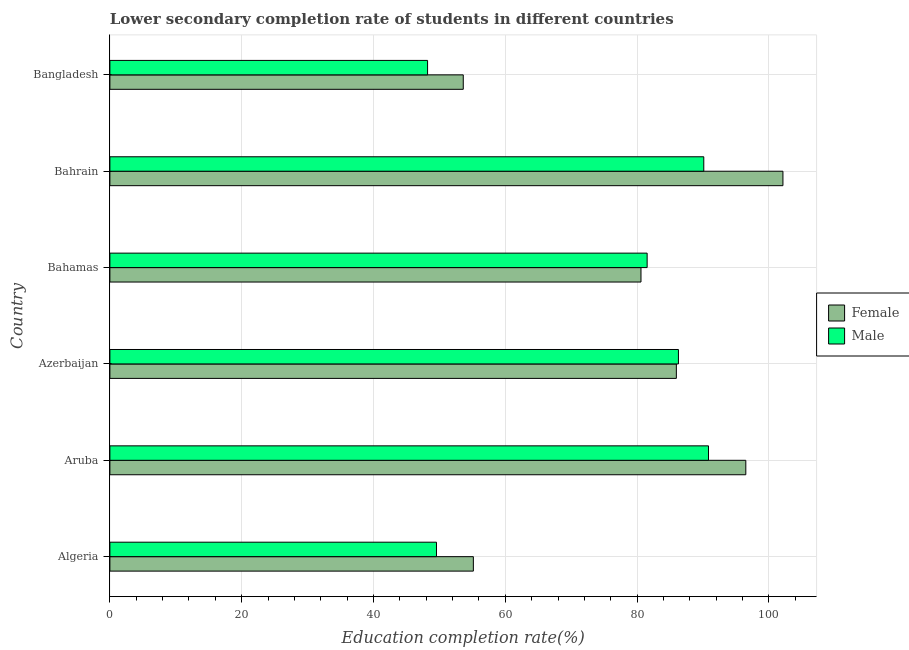How many different coloured bars are there?
Your response must be concise. 2. Are the number of bars per tick equal to the number of legend labels?
Provide a short and direct response. Yes. How many bars are there on the 3rd tick from the bottom?
Offer a terse response. 2. What is the education completion rate of male students in Aruba?
Offer a terse response. 90.82. Across all countries, what is the maximum education completion rate of male students?
Offer a terse response. 90.82. Across all countries, what is the minimum education completion rate of female students?
Give a very brief answer. 53.62. In which country was the education completion rate of female students maximum?
Offer a very short reply. Bahrain. What is the total education completion rate of female students in the graph?
Offer a very short reply. 473.9. What is the difference between the education completion rate of male students in Algeria and that in Bangladesh?
Your answer should be very brief. 1.35. What is the difference between the education completion rate of female students in Azerbaijan and the education completion rate of male students in Bahamas?
Offer a terse response. 4.43. What is the average education completion rate of female students per country?
Your answer should be compact. 78.98. What is the difference between the education completion rate of male students and education completion rate of female students in Bahrain?
Make the answer very short. -12.01. What is the ratio of the education completion rate of male students in Bahamas to that in Bangladesh?
Give a very brief answer. 1.69. What is the difference between the highest and the second highest education completion rate of male students?
Provide a short and direct response. 0.72. What is the difference between the highest and the lowest education completion rate of male students?
Your response must be concise. 42.62. What does the 2nd bar from the bottom in Azerbaijan represents?
Provide a succinct answer. Male. Are all the bars in the graph horizontal?
Your response must be concise. Yes. How many countries are there in the graph?
Provide a succinct answer. 6. What is the difference between two consecutive major ticks on the X-axis?
Provide a succinct answer. 20. Are the values on the major ticks of X-axis written in scientific E-notation?
Keep it short and to the point. No. Does the graph contain any zero values?
Give a very brief answer. No. Does the graph contain grids?
Provide a short and direct response. Yes. Where does the legend appear in the graph?
Give a very brief answer. Center right. How many legend labels are there?
Ensure brevity in your answer.  2. How are the legend labels stacked?
Give a very brief answer. Vertical. What is the title of the graph?
Give a very brief answer. Lower secondary completion rate of students in different countries. Does "Primary school" appear as one of the legend labels in the graph?
Ensure brevity in your answer.  No. What is the label or title of the X-axis?
Give a very brief answer. Education completion rate(%). What is the Education completion rate(%) in Female in Algeria?
Give a very brief answer. 55.15. What is the Education completion rate(%) of Male in Algeria?
Keep it short and to the point. 49.55. What is the Education completion rate(%) of Female in Aruba?
Your response must be concise. 96.49. What is the Education completion rate(%) of Male in Aruba?
Your answer should be compact. 90.82. What is the Education completion rate(%) in Female in Azerbaijan?
Provide a short and direct response. 85.95. What is the Education completion rate(%) in Male in Azerbaijan?
Give a very brief answer. 86.26. What is the Education completion rate(%) in Female in Bahamas?
Your response must be concise. 80.58. What is the Education completion rate(%) of Male in Bahamas?
Offer a very short reply. 81.51. What is the Education completion rate(%) in Female in Bahrain?
Provide a short and direct response. 102.12. What is the Education completion rate(%) of Male in Bahrain?
Make the answer very short. 90.11. What is the Education completion rate(%) in Female in Bangladesh?
Your answer should be very brief. 53.62. What is the Education completion rate(%) of Male in Bangladesh?
Provide a short and direct response. 48.2. Across all countries, what is the maximum Education completion rate(%) in Female?
Offer a terse response. 102.12. Across all countries, what is the maximum Education completion rate(%) of Male?
Offer a very short reply. 90.82. Across all countries, what is the minimum Education completion rate(%) in Female?
Ensure brevity in your answer.  53.62. Across all countries, what is the minimum Education completion rate(%) in Male?
Make the answer very short. 48.2. What is the total Education completion rate(%) in Female in the graph?
Offer a terse response. 473.9. What is the total Education completion rate(%) in Male in the graph?
Offer a very short reply. 446.46. What is the difference between the Education completion rate(%) in Female in Algeria and that in Aruba?
Keep it short and to the point. -41.34. What is the difference between the Education completion rate(%) of Male in Algeria and that in Aruba?
Your answer should be very brief. -41.27. What is the difference between the Education completion rate(%) in Female in Algeria and that in Azerbaijan?
Offer a terse response. -30.8. What is the difference between the Education completion rate(%) of Male in Algeria and that in Azerbaijan?
Provide a short and direct response. -36.71. What is the difference between the Education completion rate(%) of Female in Algeria and that in Bahamas?
Offer a very short reply. -25.44. What is the difference between the Education completion rate(%) of Male in Algeria and that in Bahamas?
Provide a short and direct response. -31.96. What is the difference between the Education completion rate(%) of Female in Algeria and that in Bahrain?
Your answer should be compact. -46.97. What is the difference between the Education completion rate(%) in Male in Algeria and that in Bahrain?
Give a very brief answer. -40.56. What is the difference between the Education completion rate(%) of Female in Algeria and that in Bangladesh?
Ensure brevity in your answer.  1.53. What is the difference between the Education completion rate(%) of Male in Algeria and that in Bangladesh?
Your answer should be compact. 1.35. What is the difference between the Education completion rate(%) of Female in Aruba and that in Azerbaijan?
Your answer should be very brief. 10.54. What is the difference between the Education completion rate(%) in Male in Aruba and that in Azerbaijan?
Provide a short and direct response. 4.56. What is the difference between the Education completion rate(%) in Female in Aruba and that in Bahamas?
Keep it short and to the point. 15.9. What is the difference between the Education completion rate(%) in Male in Aruba and that in Bahamas?
Provide a short and direct response. 9.31. What is the difference between the Education completion rate(%) in Female in Aruba and that in Bahrain?
Make the answer very short. -5.63. What is the difference between the Education completion rate(%) of Male in Aruba and that in Bahrain?
Offer a terse response. 0.72. What is the difference between the Education completion rate(%) in Female in Aruba and that in Bangladesh?
Your response must be concise. 42.87. What is the difference between the Education completion rate(%) in Male in Aruba and that in Bangladesh?
Offer a terse response. 42.62. What is the difference between the Education completion rate(%) of Female in Azerbaijan and that in Bahamas?
Ensure brevity in your answer.  5.37. What is the difference between the Education completion rate(%) of Male in Azerbaijan and that in Bahamas?
Provide a succinct answer. 4.75. What is the difference between the Education completion rate(%) in Female in Azerbaijan and that in Bahrain?
Provide a succinct answer. -16.17. What is the difference between the Education completion rate(%) of Male in Azerbaijan and that in Bahrain?
Offer a terse response. -3.84. What is the difference between the Education completion rate(%) of Female in Azerbaijan and that in Bangladesh?
Keep it short and to the point. 32.33. What is the difference between the Education completion rate(%) in Male in Azerbaijan and that in Bangladesh?
Make the answer very short. 38.06. What is the difference between the Education completion rate(%) in Female in Bahamas and that in Bahrain?
Your response must be concise. -21.54. What is the difference between the Education completion rate(%) in Male in Bahamas and that in Bahrain?
Offer a terse response. -8.59. What is the difference between the Education completion rate(%) in Female in Bahamas and that in Bangladesh?
Make the answer very short. 26.97. What is the difference between the Education completion rate(%) in Male in Bahamas and that in Bangladesh?
Offer a very short reply. 33.31. What is the difference between the Education completion rate(%) of Female in Bahrain and that in Bangladesh?
Offer a terse response. 48.5. What is the difference between the Education completion rate(%) of Male in Bahrain and that in Bangladesh?
Offer a terse response. 41.91. What is the difference between the Education completion rate(%) of Female in Algeria and the Education completion rate(%) of Male in Aruba?
Offer a terse response. -35.68. What is the difference between the Education completion rate(%) in Female in Algeria and the Education completion rate(%) in Male in Azerbaijan?
Give a very brief answer. -31.12. What is the difference between the Education completion rate(%) in Female in Algeria and the Education completion rate(%) in Male in Bahamas?
Your response must be concise. -26.37. What is the difference between the Education completion rate(%) of Female in Algeria and the Education completion rate(%) of Male in Bahrain?
Provide a succinct answer. -34.96. What is the difference between the Education completion rate(%) of Female in Algeria and the Education completion rate(%) of Male in Bangladesh?
Give a very brief answer. 6.94. What is the difference between the Education completion rate(%) of Female in Aruba and the Education completion rate(%) of Male in Azerbaijan?
Offer a very short reply. 10.22. What is the difference between the Education completion rate(%) in Female in Aruba and the Education completion rate(%) in Male in Bahamas?
Your answer should be very brief. 14.97. What is the difference between the Education completion rate(%) of Female in Aruba and the Education completion rate(%) of Male in Bahrain?
Offer a very short reply. 6.38. What is the difference between the Education completion rate(%) in Female in Aruba and the Education completion rate(%) in Male in Bangladesh?
Your answer should be compact. 48.28. What is the difference between the Education completion rate(%) of Female in Azerbaijan and the Education completion rate(%) of Male in Bahamas?
Provide a short and direct response. 4.43. What is the difference between the Education completion rate(%) in Female in Azerbaijan and the Education completion rate(%) in Male in Bahrain?
Provide a short and direct response. -4.16. What is the difference between the Education completion rate(%) in Female in Azerbaijan and the Education completion rate(%) in Male in Bangladesh?
Give a very brief answer. 37.75. What is the difference between the Education completion rate(%) of Female in Bahamas and the Education completion rate(%) of Male in Bahrain?
Offer a terse response. -9.53. What is the difference between the Education completion rate(%) of Female in Bahamas and the Education completion rate(%) of Male in Bangladesh?
Ensure brevity in your answer.  32.38. What is the difference between the Education completion rate(%) in Female in Bahrain and the Education completion rate(%) in Male in Bangladesh?
Provide a succinct answer. 53.92. What is the average Education completion rate(%) in Female per country?
Ensure brevity in your answer.  78.98. What is the average Education completion rate(%) in Male per country?
Make the answer very short. 74.41. What is the difference between the Education completion rate(%) in Female and Education completion rate(%) in Male in Algeria?
Your answer should be compact. 5.59. What is the difference between the Education completion rate(%) of Female and Education completion rate(%) of Male in Aruba?
Give a very brief answer. 5.66. What is the difference between the Education completion rate(%) in Female and Education completion rate(%) in Male in Azerbaijan?
Provide a short and direct response. -0.32. What is the difference between the Education completion rate(%) of Female and Education completion rate(%) of Male in Bahamas?
Your answer should be compact. -0.93. What is the difference between the Education completion rate(%) in Female and Education completion rate(%) in Male in Bahrain?
Make the answer very short. 12.01. What is the difference between the Education completion rate(%) of Female and Education completion rate(%) of Male in Bangladesh?
Provide a succinct answer. 5.41. What is the ratio of the Education completion rate(%) of Female in Algeria to that in Aruba?
Offer a terse response. 0.57. What is the ratio of the Education completion rate(%) of Male in Algeria to that in Aruba?
Your answer should be compact. 0.55. What is the ratio of the Education completion rate(%) of Female in Algeria to that in Azerbaijan?
Keep it short and to the point. 0.64. What is the ratio of the Education completion rate(%) of Male in Algeria to that in Azerbaijan?
Provide a short and direct response. 0.57. What is the ratio of the Education completion rate(%) of Female in Algeria to that in Bahamas?
Provide a short and direct response. 0.68. What is the ratio of the Education completion rate(%) in Male in Algeria to that in Bahamas?
Make the answer very short. 0.61. What is the ratio of the Education completion rate(%) in Female in Algeria to that in Bahrain?
Your response must be concise. 0.54. What is the ratio of the Education completion rate(%) in Male in Algeria to that in Bahrain?
Your response must be concise. 0.55. What is the ratio of the Education completion rate(%) in Female in Algeria to that in Bangladesh?
Give a very brief answer. 1.03. What is the ratio of the Education completion rate(%) of Male in Algeria to that in Bangladesh?
Your answer should be very brief. 1.03. What is the ratio of the Education completion rate(%) in Female in Aruba to that in Azerbaijan?
Your response must be concise. 1.12. What is the ratio of the Education completion rate(%) in Male in Aruba to that in Azerbaijan?
Make the answer very short. 1.05. What is the ratio of the Education completion rate(%) of Female in Aruba to that in Bahamas?
Offer a very short reply. 1.2. What is the ratio of the Education completion rate(%) in Male in Aruba to that in Bahamas?
Give a very brief answer. 1.11. What is the ratio of the Education completion rate(%) in Female in Aruba to that in Bahrain?
Make the answer very short. 0.94. What is the ratio of the Education completion rate(%) in Female in Aruba to that in Bangladesh?
Provide a succinct answer. 1.8. What is the ratio of the Education completion rate(%) of Male in Aruba to that in Bangladesh?
Provide a succinct answer. 1.88. What is the ratio of the Education completion rate(%) of Female in Azerbaijan to that in Bahamas?
Make the answer very short. 1.07. What is the ratio of the Education completion rate(%) of Male in Azerbaijan to that in Bahamas?
Offer a very short reply. 1.06. What is the ratio of the Education completion rate(%) in Female in Azerbaijan to that in Bahrain?
Your answer should be very brief. 0.84. What is the ratio of the Education completion rate(%) in Male in Azerbaijan to that in Bahrain?
Offer a terse response. 0.96. What is the ratio of the Education completion rate(%) in Female in Azerbaijan to that in Bangladesh?
Offer a very short reply. 1.6. What is the ratio of the Education completion rate(%) in Male in Azerbaijan to that in Bangladesh?
Make the answer very short. 1.79. What is the ratio of the Education completion rate(%) in Female in Bahamas to that in Bahrain?
Offer a terse response. 0.79. What is the ratio of the Education completion rate(%) in Male in Bahamas to that in Bahrain?
Your answer should be very brief. 0.9. What is the ratio of the Education completion rate(%) of Female in Bahamas to that in Bangladesh?
Make the answer very short. 1.5. What is the ratio of the Education completion rate(%) in Male in Bahamas to that in Bangladesh?
Provide a short and direct response. 1.69. What is the ratio of the Education completion rate(%) of Female in Bahrain to that in Bangladesh?
Provide a short and direct response. 1.9. What is the ratio of the Education completion rate(%) in Male in Bahrain to that in Bangladesh?
Your response must be concise. 1.87. What is the difference between the highest and the second highest Education completion rate(%) in Female?
Give a very brief answer. 5.63. What is the difference between the highest and the second highest Education completion rate(%) of Male?
Offer a terse response. 0.72. What is the difference between the highest and the lowest Education completion rate(%) in Female?
Offer a very short reply. 48.5. What is the difference between the highest and the lowest Education completion rate(%) in Male?
Keep it short and to the point. 42.62. 